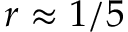<formula> <loc_0><loc_0><loc_500><loc_500>r \approx 1 / 5</formula> 